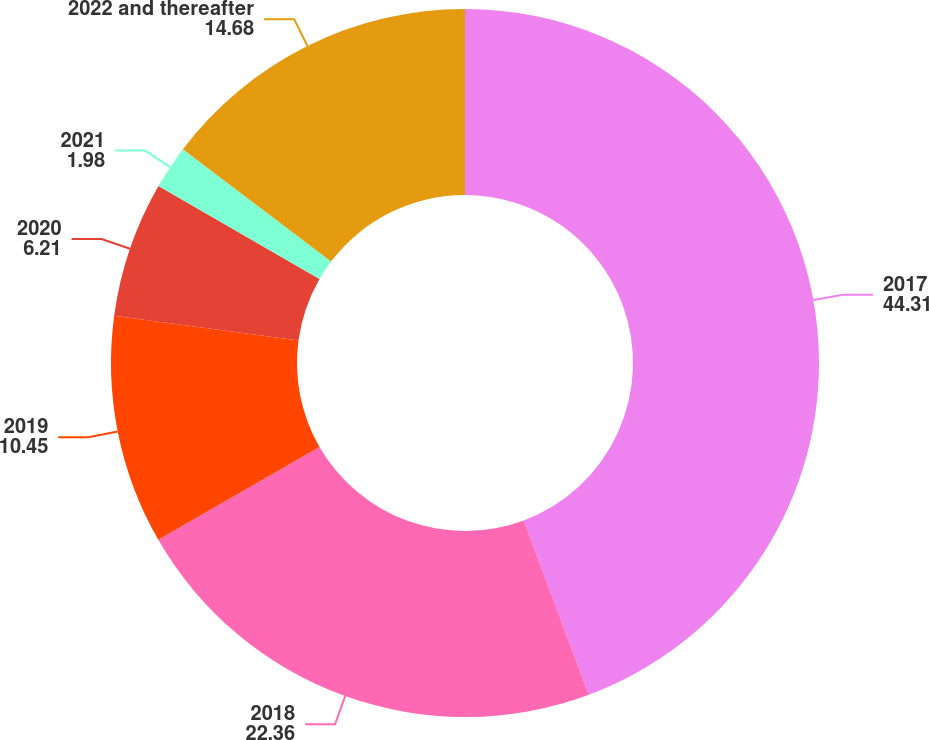Convert chart to OTSL. <chart><loc_0><loc_0><loc_500><loc_500><pie_chart><fcel>2017<fcel>2018<fcel>2019<fcel>2020<fcel>2021<fcel>2022 and thereafter<nl><fcel>44.31%<fcel>22.36%<fcel>10.45%<fcel>6.21%<fcel>1.98%<fcel>14.68%<nl></chart> 